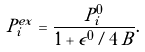<formula> <loc_0><loc_0><loc_500><loc_500>P _ { i } ^ { e x } = \frac { P _ { i } ^ { 0 } } { 1 + \epsilon ^ { 0 } / 4 \, B } .</formula> 